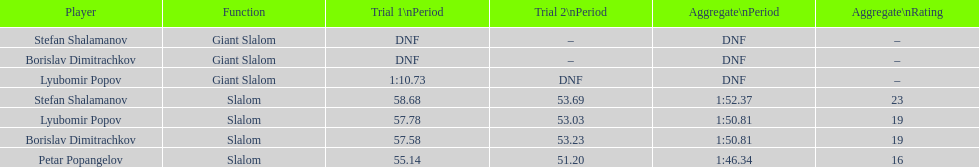Who has the highest rank? Petar Popangelov. 